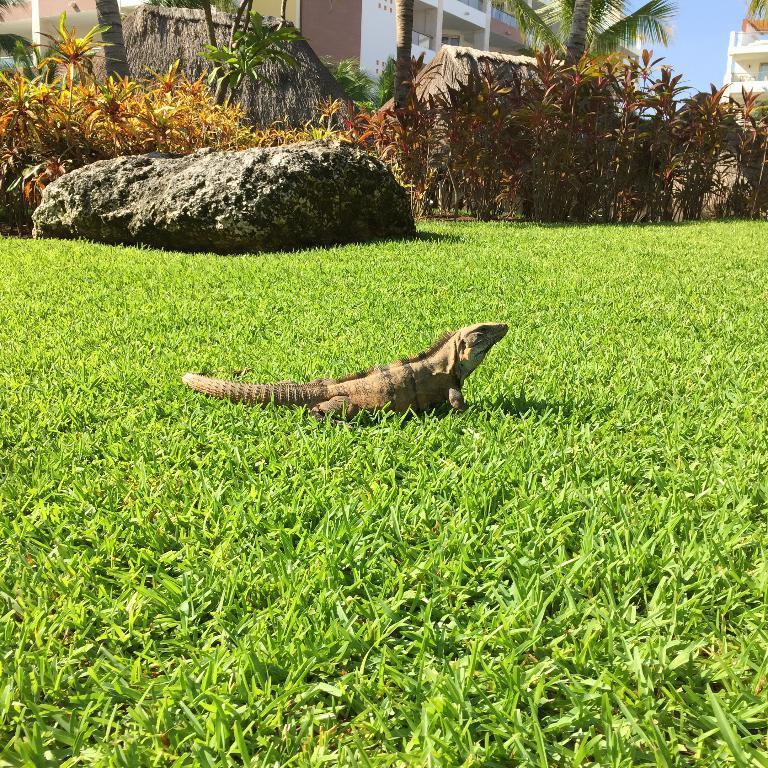Please provide a concise description of this image. In this picture we can see a reptile on the grass, in the background we can find a rock, plants, trees and houses. 